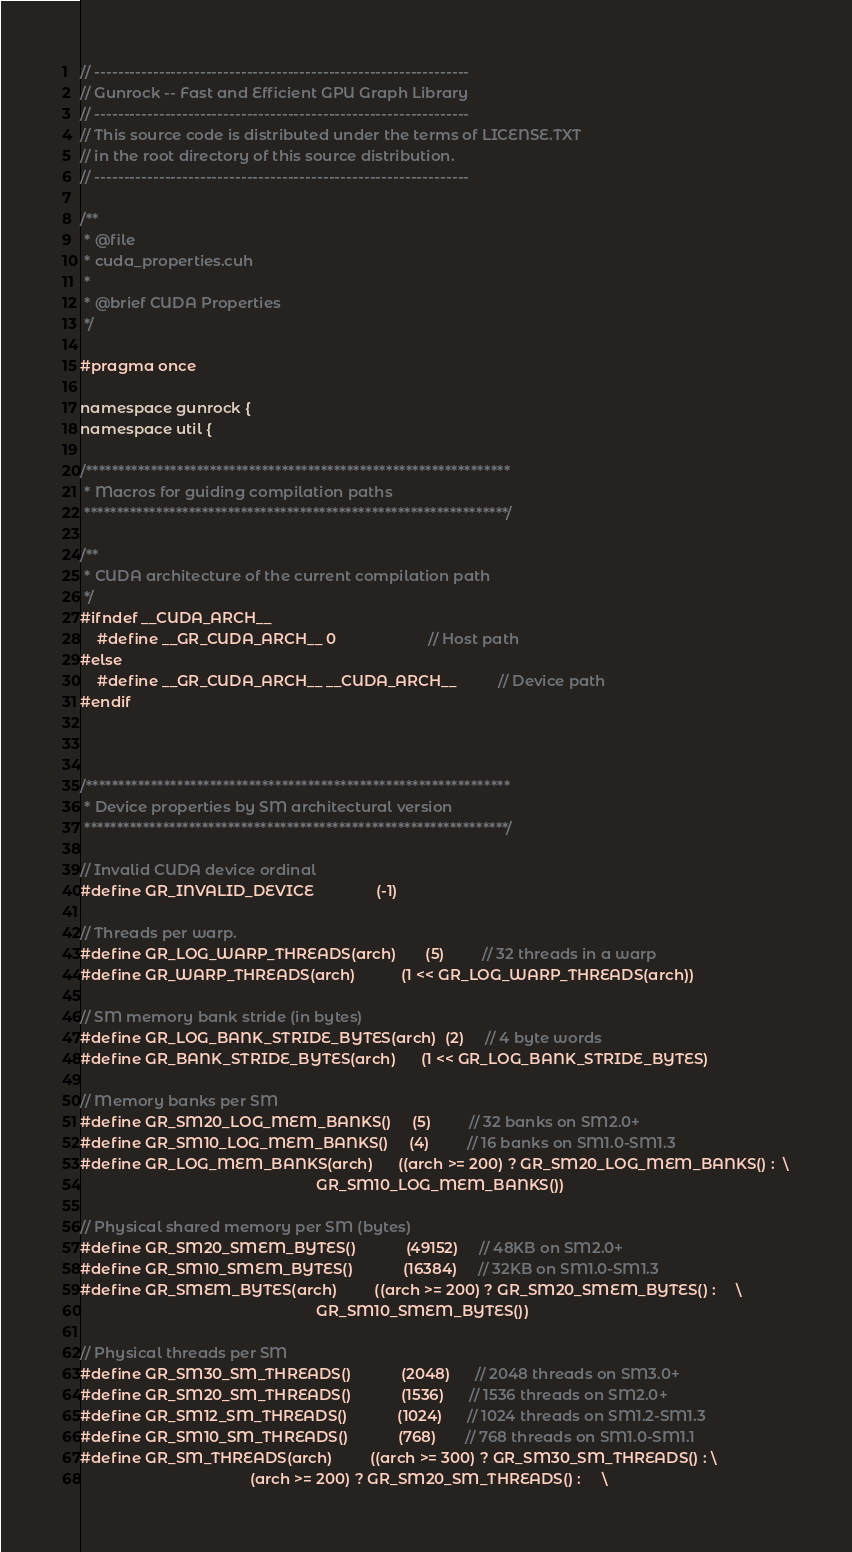<code> <loc_0><loc_0><loc_500><loc_500><_Cuda_>// ----------------------------------------------------------------
// Gunrock -- Fast and Efficient GPU Graph Library
// ----------------------------------------------------------------
// This source code is distributed under the terms of LICENSE.TXT
// in the root directory of this source distribution.
// ----------------------------------------------------------------

/**
 * @file
 * cuda_properties.cuh
 *
 * @brief CUDA Properties
 */

#pragma once

namespace gunrock {
namespace util {

/*****************************************************************
 * Macros for guiding compilation paths
 *****************************************************************/

/**
 * CUDA architecture of the current compilation path
 */
#ifndef __CUDA_ARCH__
    #define __GR_CUDA_ARCH__ 0                      // Host path
#else
    #define __GR_CUDA_ARCH__ __CUDA_ARCH__          // Device path
#endif



/*****************************************************************
 * Device properties by SM architectural version
 *****************************************************************/

// Invalid CUDA device ordinal
#define GR_INVALID_DEVICE               (-1)

// Threads per warp. 
#define GR_LOG_WARP_THREADS(arch)       (5)         // 32 threads in a warp 
#define GR_WARP_THREADS(arch)           (1 << GR_LOG_WARP_THREADS(arch))

// SM memory bank stride (in bytes)
#define GR_LOG_BANK_STRIDE_BYTES(arch)  (2)     // 4 byte words
#define GR_BANK_STRIDE_BYTES(arch)      (1 << GR_LOG_BANK_STRIDE_BYTES)

// Memory banks per SM
#define GR_SM20_LOG_MEM_BANKS()     (5)         // 32 banks on SM2.0+
#define GR_SM10_LOG_MEM_BANKS()     (4)         // 16 banks on SM1.0-SM1.3
#define GR_LOG_MEM_BANKS(arch)      ((arch >= 200) ? GR_SM20_LOG_MEM_BANKS() :  \
                                                         GR_SM10_LOG_MEM_BANKS())       

// Physical shared memory per SM (bytes)
#define GR_SM20_SMEM_BYTES()            (49152)     // 48KB on SM2.0+
#define GR_SM10_SMEM_BYTES()            (16384)     // 32KB on SM1.0-SM1.3
#define GR_SMEM_BYTES(arch)         ((arch >= 200) ? GR_SM20_SMEM_BYTES() :     \
                                                         GR_SM10_SMEM_BYTES())      

// Physical threads per SM
#define GR_SM30_SM_THREADS()            (2048)      // 2048 threads on SM3.0+
#define GR_SM20_SM_THREADS()            (1536)      // 1536 threads on SM2.0+
#define GR_SM12_SM_THREADS()            (1024)      // 1024 threads on SM1.2-SM1.3
#define GR_SM10_SM_THREADS()            (768)       // 768 threads on SM1.0-SM1.1
#define GR_SM_THREADS(arch)         ((arch >= 300) ? GR_SM30_SM_THREADS() : \
                                         (arch >= 200) ? GR_SM20_SM_THREADS() :     \</code> 